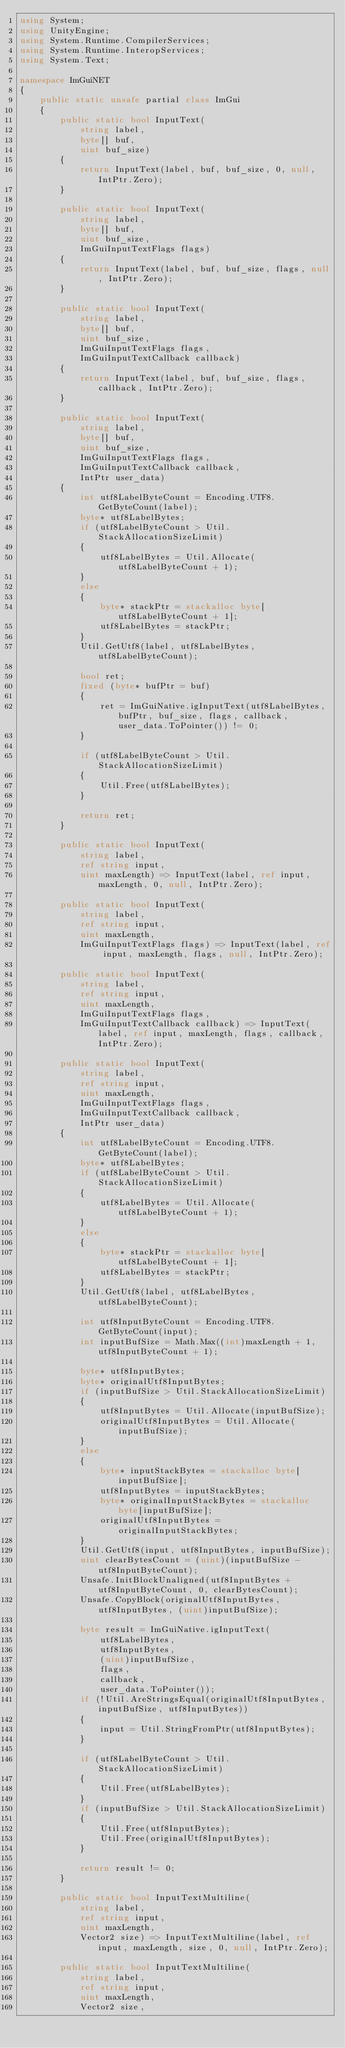Convert code to text. <code><loc_0><loc_0><loc_500><loc_500><_C#_>using System;
using UnityEngine;
using System.Runtime.CompilerServices;
using System.Runtime.InteropServices;
using System.Text;

namespace ImGuiNET
{
    public static unsafe partial class ImGui
    {
        public static bool InputText(
            string label,
            byte[] buf,
            uint buf_size)
        {
            return InputText(label, buf, buf_size, 0, null, IntPtr.Zero);
        }

        public static bool InputText(
            string label,
            byte[] buf,
            uint buf_size,
            ImGuiInputTextFlags flags)
        {
            return InputText(label, buf, buf_size, flags, null, IntPtr.Zero);
        }

        public static bool InputText(
            string label,
            byte[] buf,
            uint buf_size,
            ImGuiInputTextFlags flags,
            ImGuiInputTextCallback callback)
        {
            return InputText(label, buf, buf_size, flags, callback, IntPtr.Zero);
        }

        public static bool InputText(
            string label,
            byte[] buf,
            uint buf_size,
            ImGuiInputTextFlags flags,
            ImGuiInputTextCallback callback,
            IntPtr user_data)
        {
            int utf8LabelByteCount = Encoding.UTF8.GetByteCount(label);
            byte* utf8LabelBytes;
            if (utf8LabelByteCount > Util.StackAllocationSizeLimit)
            {
                utf8LabelBytes = Util.Allocate(utf8LabelByteCount + 1);
            }
            else
            {
                byte* stackPtr = stackalloc byte[utf8LabelByteCount + 1];
                utf8LabelBytes = stackPtr;
            }
            Util.GetUtf8(label, utf8LabelBytes, utf8LabelByteCount);

            bool ret;
            fixed (byte* bufPtr = buf)
            {
                ret = ImGuiNative.igInputText(utf8LabelBytes, bufPtr, buf_size, flags, callback, user_data.ToPointer()) != 0;
            }

            if (utf8LabelByteCount > Util.StackAllocationSizeLimit)
            {
                Util.Free(utf8LabelBytes);
            }

            return ret;
        }

        public static bool InputText(
            string label,
            ref string input,
            uint maxLength) => InputText(label, ref input, maxLength, 0, null, IntPtr.Zero);

        public static bool InputText(
            string label,
            ref string input,
            uint maxLength,
            ImGuiInputTextFlags flags) => InputText(label, ref input, maxLength, flags, null, IntPtr.Zero);

        public static bool InputText(
            string label,
            ref string input,
            uint maxLength,
            ImGuiInputTextFlags flags,
            ImGuiInputTextCallback callback) => InputText(label, ref input, maxLength, flags, callback, IntPtr.Zero);

        public static bool InputText(
            string label,
            ref string input,
            uint maxLength,
            ImGuiInputTextFlags flags,
            ImGuiInputTextCallback callback,
            IntPtr user_data)
        {
            int utf8LabelByteCount = Encoding.UTF8.GetByteCount(label);
            byte* utf8LabelBytes;
            if (utf8LabelByteCount > Util.StackAllocationSizeLimit)
            {
                utf8LabelBytes = Util.Allocate(utf8LabelByteCount + 1);
            }
            else
            {
                byte* stackPtr = stackalloc byte[utf8LabelByteCount + 1];
                utf8LabelBytes = stackPtr;
            }
            Util.GetUtf8(label, utf8LabelBytes, utf8LabelByteCount);

            int utf8InputByteCount = Encoding.UTF8.GetByteCount(input);
            int inputBufSize = Math.Max((int)maxLength + 1, utf8InputByteCount + 1);

            byte* utf8InputBytes;
            byte* originalUtf8InputBytes;
            if (inputBufSize > Util.StackAllocationSizeLimit)
            {
                utf8InputBytes = Util.Allocate(inputBufSize);
                originalUtf8InputBytes = Util.Allocate(inputBufSize);
            }
            else
            {
                byte* inputStackBytes = stackalloc byte[inputBufSize];
                utf8InputBytes = inputStackBytes;
                byte* originalInputStackBytes = stackalloc byte[inputBufSize];
                originalUtf8InputBytes = originalInputStackBytes;
            }
            Util.GetUtf8(input, utf8InputBytes, inputBufSize);
            uint clearBytesCount = (uint)(inputBufSize - utf8InputByteCount);
            Unsafe.InitBlockUnaligned(utf8InputBytes + utf8InputByteCount, 0, clearBytesCount);
            Unsafe.CopyBlock(originalUtf8InputBytes, utf8InputBytes, (uint)inputBufSize);

            byte result = ImGuiNative.igInputText(
                utf8LabelBytes,
                utf8InputBytes,
                (uint)inputBufSize,
                flags,
                callback,
                user_data.ToPointer());
            if (!Util.AreStringsEqual(originalUtf8InputBytes, inputBufSize, utf8InputBytes))
            {
                input = Util.StringFromPtr(utf8InputBytes);
            }

            if (utf8LabelByteCount > Util.StackAllocationSizeLimit)
            {
                Util.Free(utf8LabelBytes);
            }
            if (inputBufSize > Util.StackAllocationSizeLimit)
            {
                Util.Free(utf8InputBytes);
                Util.Free(originalUtf8InputBytes);
            }

            return result != 0;
        }

        public static bool InputTextMultiline(
            string label,
            ref string input,
            uint maxLength,
            Vector2 size) => InputTextMultiline(label, ref input, maxLength, size, 0, null, IntPtr.Zero);

        public static bool InputTextMultiline(
            string label,
            ref string input,
            uint maxLength,
            Vector2 size,</code> 